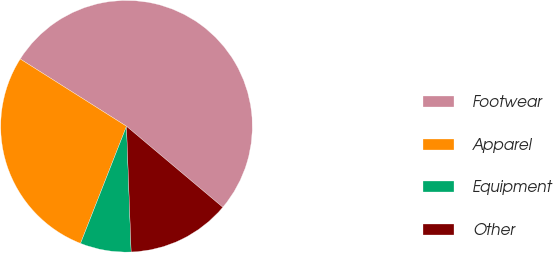Convert chart. <chart><loc_0><loc_0><loc_500><loc_500><pie_chart><fcel>Footwear<fcel>Apparel<fcel>Equipment<fcel>Other<nl><fcel>52.15%<fcel>28.03%<fcel>6.54%<fcel>13.28%<nl></chart> 